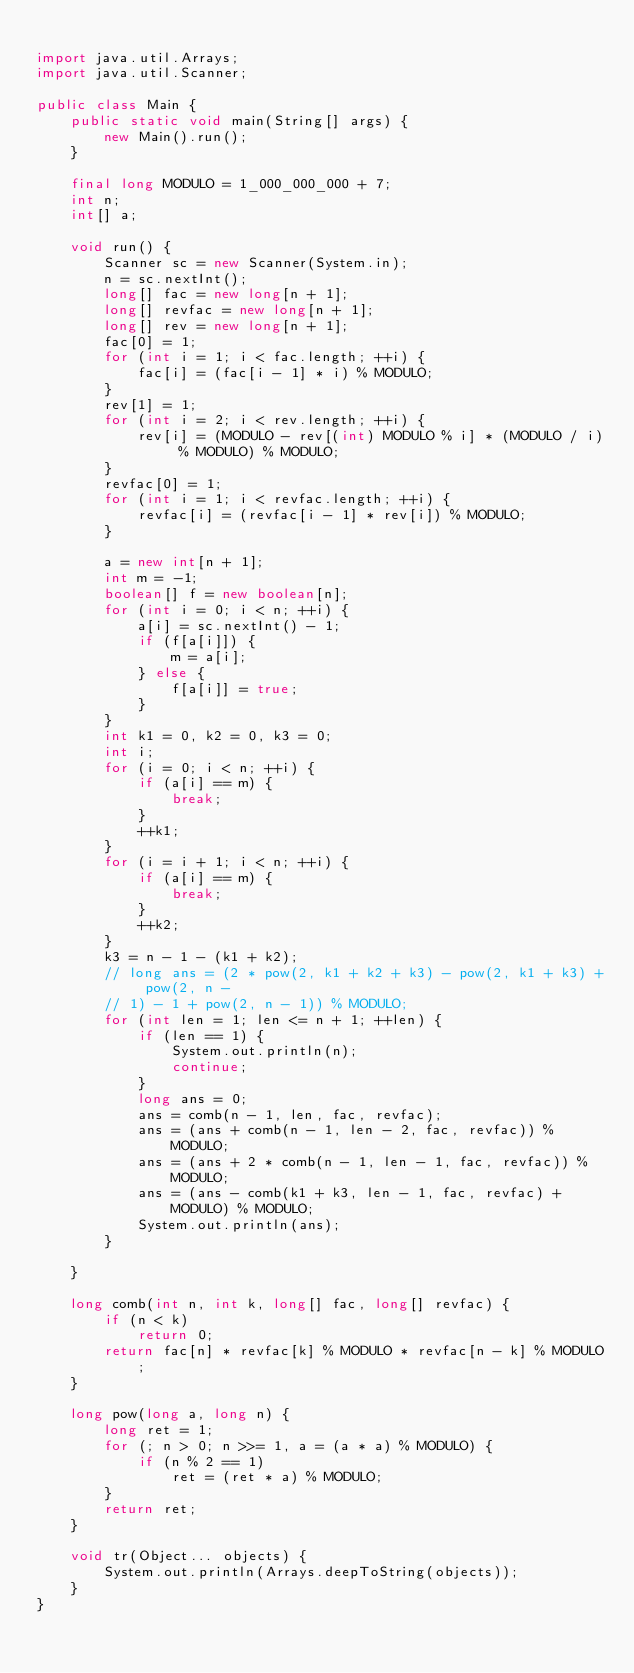Convert code to text. <code><loc_0><loc_0><loc_500><loc_500><_Java_>
import java.util.Arrays;
import java.util.Scanner;

public class Main {
	public static void main(String[] args) {
		new Main().run();
	}

	final long MODULO = 1_000_000_000 + 7;
	int n;
	int[] a;

	void run() {
		Scanner sc = new Scanner(System.in);
		n = sc.nextInt();
		long[] fac = new long[n + 1];
		long[] revfac = new long[n + 1];
		long[] rev = new long[n + 1];
		fac[0] = 1;
		for (int i = 1; i < fac.length; ++i) {
			fac[i] = (fac[i - 1] * i) % MODULO;
		}
		rev[1] = 1;
		for (int i = 2; i < rev.length; ++i) {
			rev[i] = (MODULO - rev[(int) MODULO % i] * (MODULO / i) % MODULO) % MODULO;
		}
		revfac[0] = 1;
		for (int i = 1; i < revfac.length; ++i) {
			revfac[i] = (revfac[i - 1] * rev[i]) % MODULO;
		}

		a = new int[n + 1];
		int m = -1;
		boolean[] f = new boolean[n];
		for (int i = 0; i < n; ++i) {
			a[i] = sc.nextInt() - 1;
			if (f[a[i]]) {
				m = a[i];
			} else {
				f[a[i]] = true;
			}
		}
		int k1 = 0, k2 = 0, k3 = 0;
		int i;
		for (i = 0; i < n; ++i) {
			if (a[i] == m) {
				break;
			}
			++k1;
		}
		for (i = i + 1; i < n; ++i) {
			if (a[i] == m) {
				break;
			}
			++k2;
		}
		k3 = n - 1 - (k1 + k2);
		// long ans = (2 * pow(2, k1 + k2 + k3) - pow(2, k1 + k3) + pow(2, n -
		// 1) - 1 + pow(2, n - 1)) % MODULO;
		for (int len = 1; len <= n + 1; ++len) {
			if (len == 1) {
				System.out.println(n);
				continue;
			}
			long ans = 0;
			ans = comb(n - 1, len, fac, revfac);
			ans = (ans + comb(n - 1, len - 2, fac, revfac)) % MODULO;
			ans = (ans + 2 * comb(n - 1, len - 1, fac, revfac)) % MODULO;
			ans = (ans - comb(k1 + k3, len - 1, fac, revfac) + MODULO) % MODULO;
			System.out.println(ans);
		}

	}

	long comb(int n, int k, long[] fac, long[] revfac) {
		if (n < k)
			return 0;
		return fac[n] * revfac[k] % MODULO * revfac[n - k] % MODULO;
	}

	long pow(long a, long n) {
		long ret = 1;
		for (; n > 0; n >>= 1, a = (a * a) % MODULO) {
			if (n % 2 == 1)
				ret = (ret * a) % MODULO;
		}
		return ret;
	}

	void tr(Object... objects) {
		System.out.println(Arrays.deepToString(objects));
	}
}
</code> 